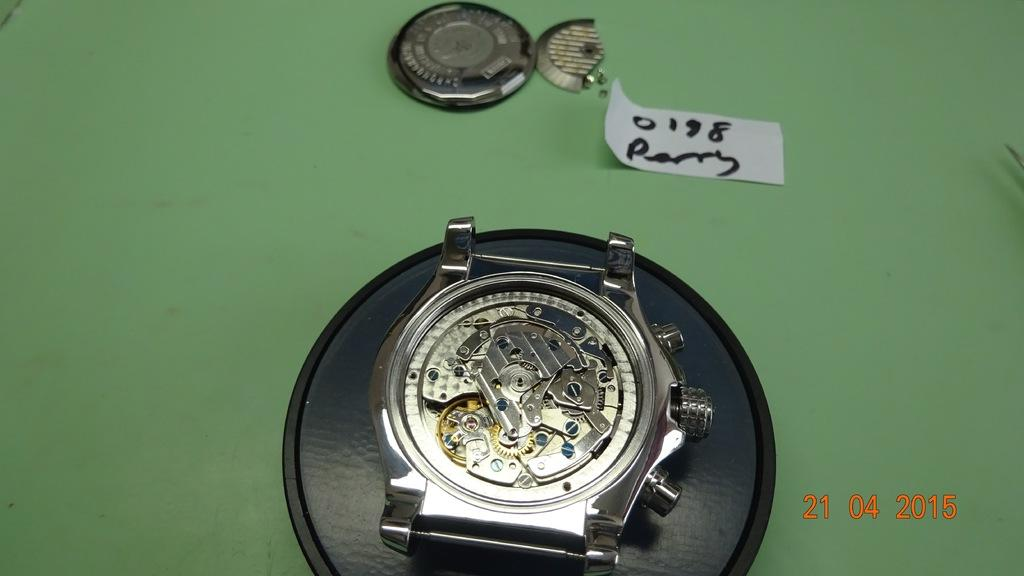<image>
Provide a brief description of the given image. A watch with its face taken off on April 21 2015. 